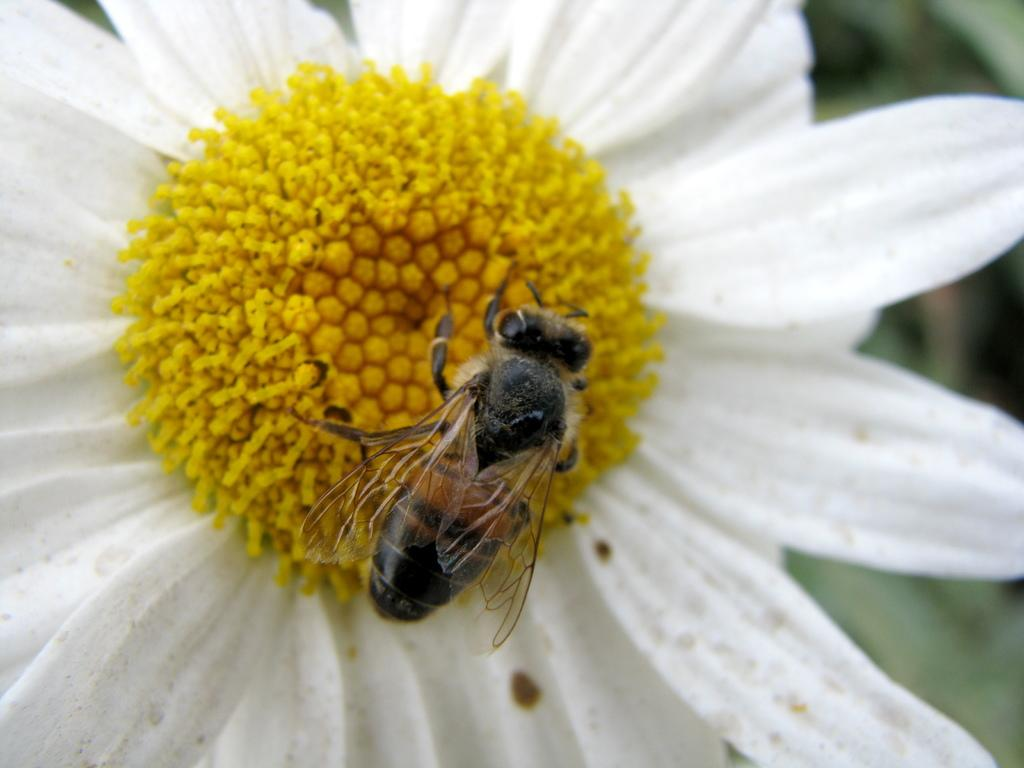What is the main subject of the picture? The main subject of the picture is a bee. Where is the bee located in the image? The bee is sitting on a flower. Can you describe the flower? The flower has white petals. What are the main features of the bee? The bee has a head, wings, and a body. How is the background of the image depicted? The backdrop of the image is blurred. What is the name of the nation that the bee represents in the image? There is no indication in the image that the bee represents a nation, as it is a natural subject in its environment. 